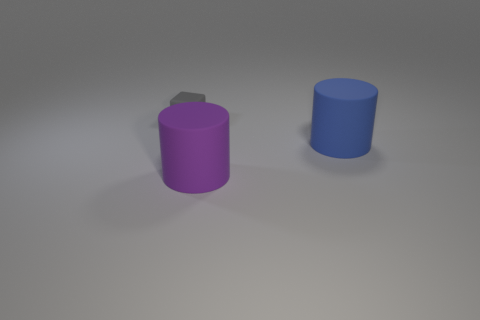Is there anything else that is the same size as the purple object?
Provide a succinct answer. Yes. Is there a purple matte cylinder?
Make the answer very short. Yes. What material is the large cylinder left of the big rubber cylinder that is to the right of the rubber cylinder that is in front of the blue matte object?
Offer a terse response. Rubber. There is a tiny gray rubber object; is it the same shape as the object in front of the large blue cylinder?
Provide a short and direct response. No. What number of other big blue matte things have the same shape as the big blue thing?
Make the answer very short. 0. What is the shape of the tiny thing?
Give a very brief answer. Cube. There is a thing that is to the left of the object in front of the big blue thing; what is its size?
Your answer should be compact. Small. What number of things are yellow metal blocks or large blue rubber cylinders?
Make the answer very short. 1. Is the shape of the purple thing the same as the tiny gray thing?
Make the answer very short. No. Are there any big blue things made of the same material as the block?
Your answer should be compact. Yes. 